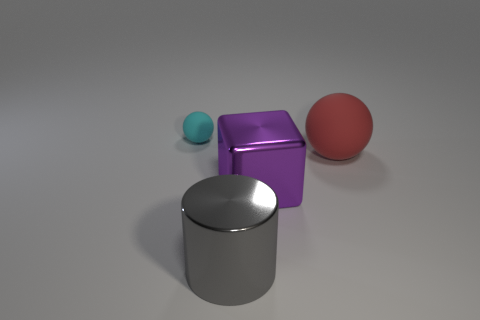Do the large sphere and the big block that is on the right side of the tiny matte ball have the same color?
Offer a very short reply. No. Are there more cyan matte blocks than cylinders?
Offer a terse response. No. Are there any other things that have the same color as the metal cylinder?
Offer a terse response. No. How many other objects are there of the same size as the red matte object?
Offer a terse response. 2. What is the material of the cube that is left of the ball to the right of the matte sphere to the left of the red thing?
Your answer should be compact. Metal. Is the gray cylinder made of the same material as the large thing behind the purple object?
Ensure brevity in your answer.  No. Is the number of shiny things in front of the big purple object less than the number of large red things that are on the right side of the red rubber ball?
Provide a succinct answer. No. What number of blocks are the same material as the large red sphere?
Your answer should be compact. 0. There is a matte thing that is to the left of the matte ball in front of the cyan matte thing; is there a small cyan sphere that is behind it?
Provide a succinct answer. No. What number of balls are big red matte things or small cyan rubber objects?
Ensure brevity in your answer.  2. 